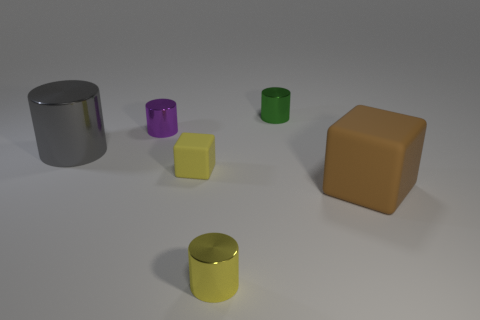What materials do the objects in the image appear to be made of? The objects in the image appear to be made from various materials. The cylinders and cubes have a shiny, possibly metallic surface, suggesting they could be made of metal or plastic with a reflective coating. Are the objects arranged in any specific pattern? The objects are not arranged in a specific pattern. They are placed randomly across the surface, with varying distances between them, which does not indicate any deliberate pattern or arrangement. 